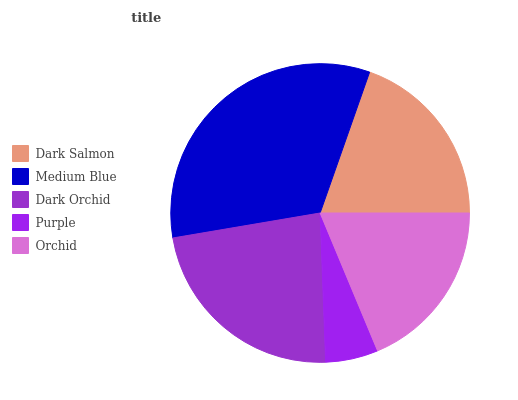Is Purple the minimum?
Answer yes or no. Yes. Is Medium Blue the maximum?
Answer yes or no. Yes. Is Dark Orchid the minimum?
Answer yes or no. No. Is Dark Orchid the maximum?
Answer yes or no. No. Is Medium Blue greater than Dark Orchid?
Answer yes or no. Yes. Is Dark Orchid less than Medium Blue?
Answer yes or no. Yes. Is Dark Orchid greater than Medium Blue?
Answer yes or no. No. Is Medium Blue less than Dark Orchid?
Answer yes or no. No. Is Dark Salmon the high median?
Answer yes or no. Yes. Is Dark Salmon the low median?
Answer yes or no. Yes. Is Dark Orchid the high median?
Answer yes or no. No. Is Dark Orchid the low median?
Answer yes or no. No. 